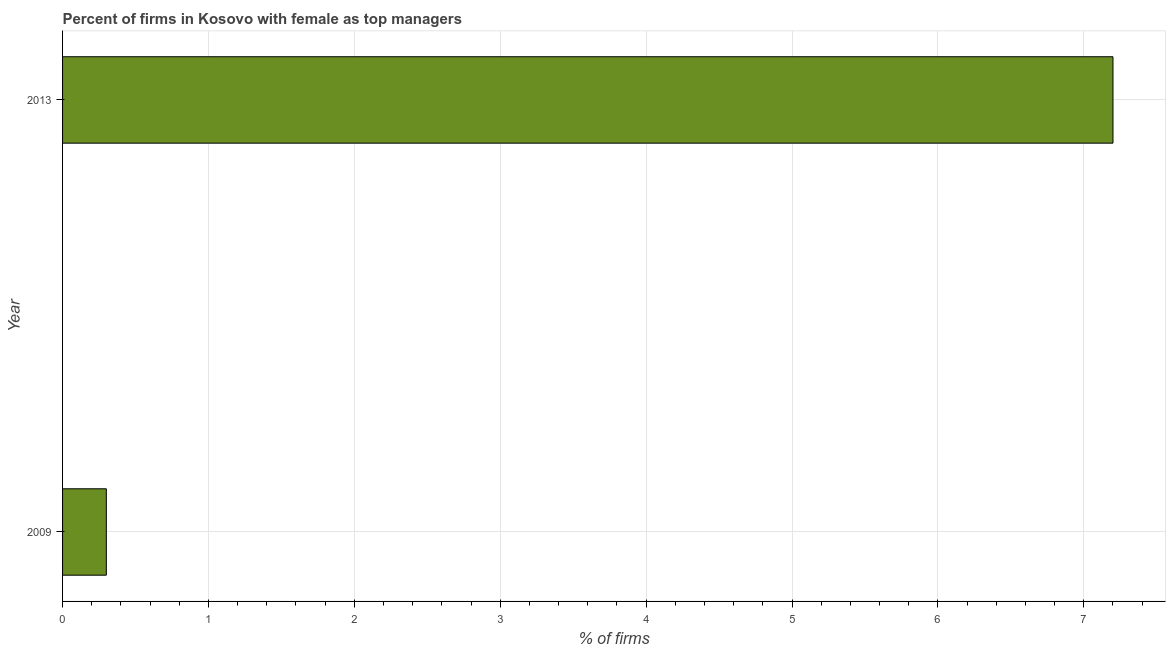What is the title of the graph?
Provide a succinct answer. Percent of firms in Kosovo with female as top managers. What is the label or title of the X-axis?
Your response must be concise. % of firms. What is the label or title of the Y-axis?
Give a very brief answer. Year. In which year was the percentage of firms with female as top manager maximum?
Your answer should be very brief. 2013. What is the average percentage of firms with female as top manager per year?
Offer a terse response. 3.75. What is the median percentage of firms with female as top manager?
Your answer should be compact. 3.75. In how many years, is the percentage of firms with female as top manager greater than 3.8 %?
Your answer should be compact. 1. Do a majority of the years between 2009 and 2013 (inclusive) have percentage of firms with female as top manager greater than 2.8 %?
Offer a terse response. No. What is the ratio of the percentage of firms with female as top manager in 2009 to that in 2013?
Provide a short and direct response. 0.04. In how many years, is the percentage of firms with female as top manager greater than the average percentage of firms with female as top manager taken over all years?
Your answer should be very brief. 1. How many bars are there?
Give a very brief answer. 2. Are all the bars in the graph horizontal?
Keep it short and to the point. Yes. What is the difference between two consecutive major ticks on the X-axis?
Keep it short and to the point. 1. What is the % of firms in 2009?
Give a very brief answer. 0.3. What is the difference between the % of firms in 2009 and 2013?
Your answer should be compact. -6.9. What is the ratio of the % of firms in 2009 to that in 2013?
Offer a terse response. 0.04. 